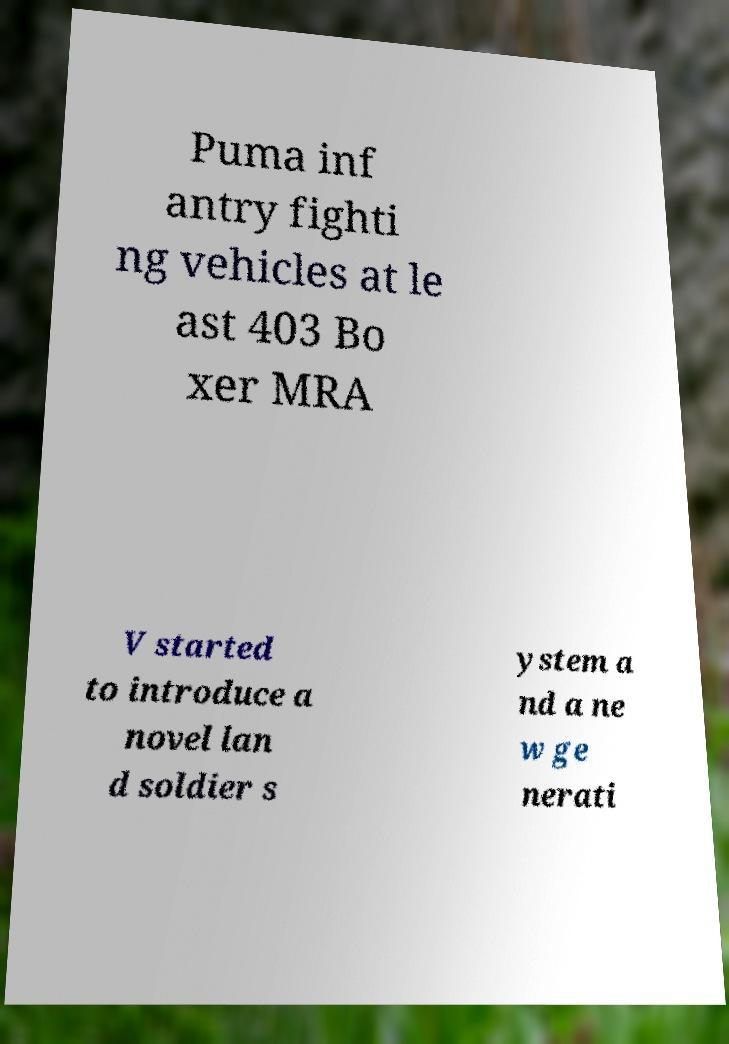Can you accurately transcribe the text from the provided image for me? Puma inf antry fighti ng vehicles at le ast 403 Bo xer MRA V started to introduce a novel lan d soldier s ystem a nd a ne w ge nerati 